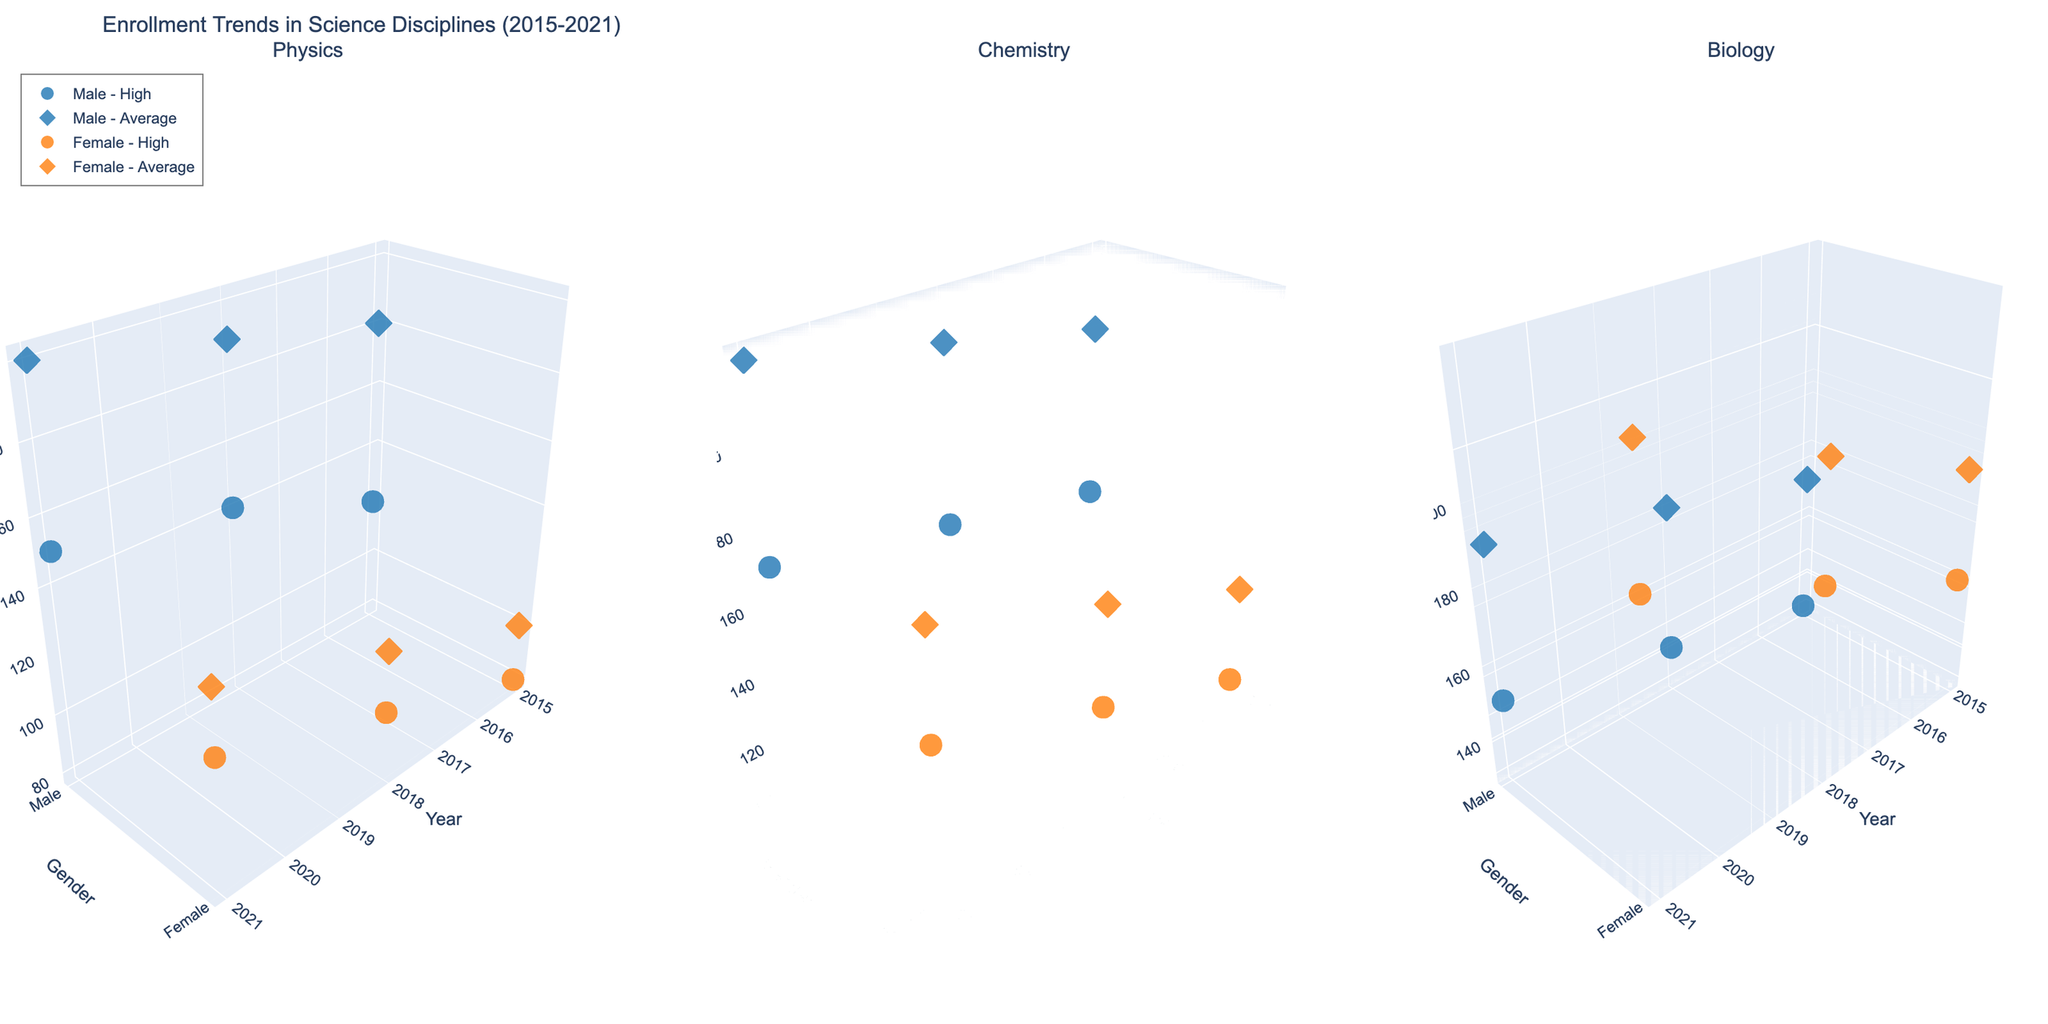What is the overall title of the figure? Look at the top center of the figure for the main title text. It describes what the figure is about.
Answer: Enrollment Trends in Science Disciplines (2015-2021) Which discipline shows the highest enrollment for high-performing female students in 2021? Focus on the three subplots and specifically note the enrollment of high-performing female students in the year 2021 for each discipline. The highest enrollment is in the subplot with the highest z-value in this category.
Answer: Biology How did the enrollment for average-performing female students in Physics change from 2015 to 2021? In the subplot for Physics, observe the enrollment values along the z-axis for average-performing female students for the years 2015 and 2021, then calculate the difference.
Answer: Increased by 40 In which year did high-performing male students have the lowest enrollment in Chemistry? In the Chemistry subplot, look at the data points for high-performing male students over all the years. Identify the year corresponding to the lowest z-value.
Answer: 2015 Compare the enrollment trends for high-performing students in Biology for both genders in 2021. Which gender has higher enrollment? In the Biology subplot for the year 2021, compare the enrollment values (z-axis) for high-performing male and female students.
Answer: Female How does the enrollment of average-performing male students in Chemistry in 2018 compare to 2021? Observe the enrollment values for average-performing male students in the Chemistry subplot for the years 2018 and 2021 and compare them by calculating the difference.
Answer: Increased by 10 Which gender and performance category had the smallest enrollment in Physics in 2018? In the Physics subplot for the year 2018, compare the enrollment values across all combinations of gender and performance categories to find the smallest value.
Answer: Female - High What is the trend in the enrollment of high-performing female students in Biology from 2015 to 2021? In the Biology subplot, note the enrollment values for high-performing female students from 2015 to 2021 and describe the trend.
Answer: Increasing How does the enrollment for average-performing female students in Chemistry in 2021 compare to that in Physics in the same year? Look at the enrollment values for average-performing female students in the Chemistry and Physics subplots for the year 2021 and compare them.
Answer: Higher in Chemistry Which discipline shows the most significant increase in enrollment of high-performing male students from 2015 to 2021? Compare the enrollment values in each discipline's subplot for high-performing male students from 2015 to 2021. Calculate and compare the increases.
Answer: Chemistry 